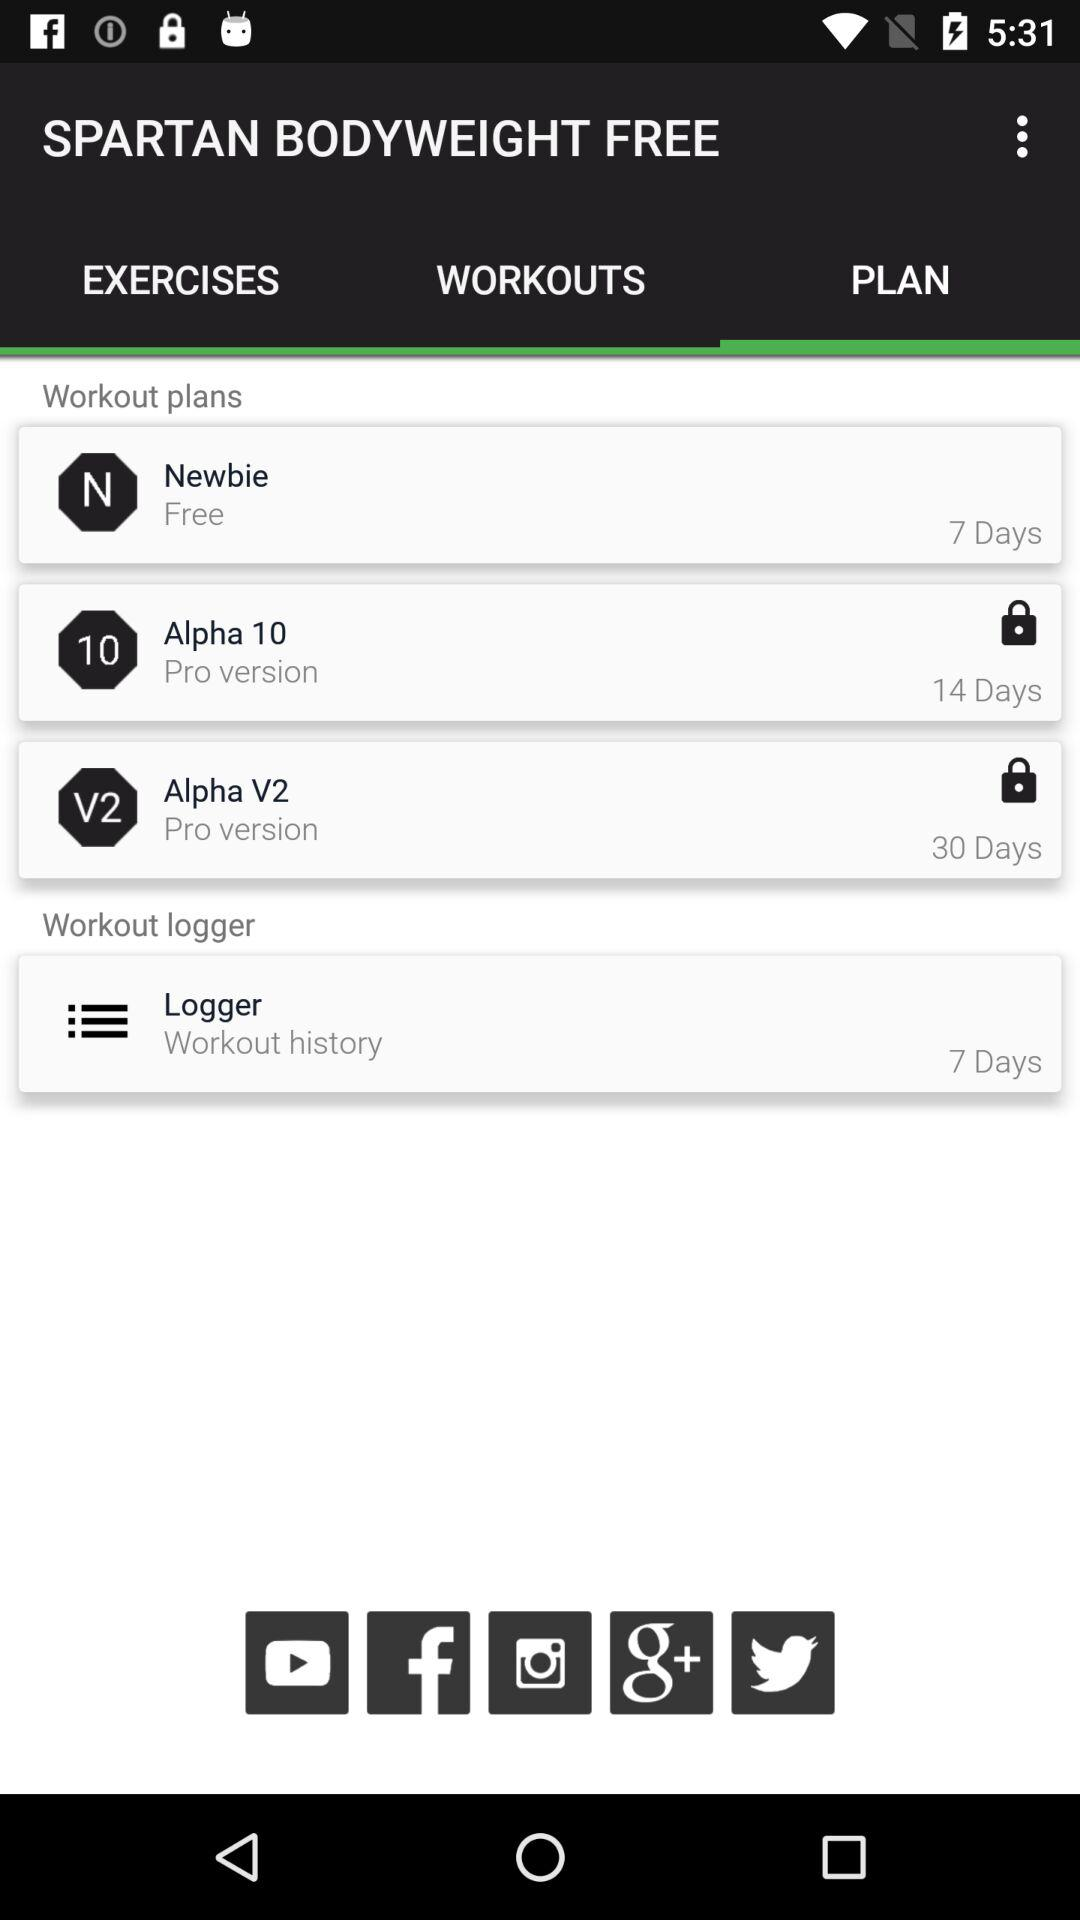How many workout plans are available?
Answer the question using a single word or phrase. 3 